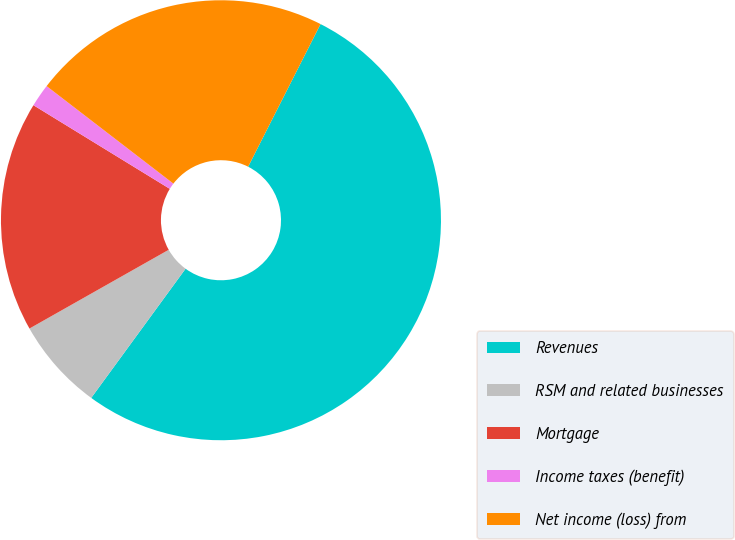Convert chart. <chart><loc_0><loc_0><loc_500><loc_500><pie_chart><fcel>Revenues<fcel>RSM and related businesses<fcel>Mortgage<fcel>Income taxes (benefit)<fcel>Net income (loss) from<nl><fcel>52.57%<fcel>6.77%<fcel>16.95%<fcel>1.68%<fcel>22.04%<nl></chart> 